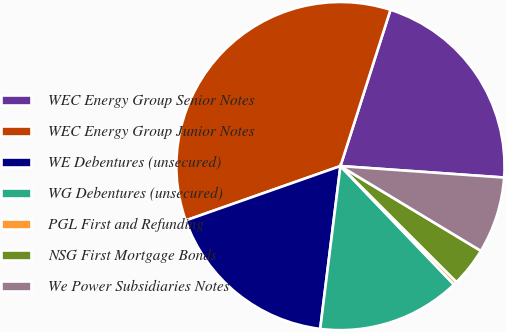Convert chart. <chart><loc_0><loc_0><loc_500><loc_500><pie_chart><fcel>WEC Energy Group Senior Notes<fcel>WEC Energy Group Junior Notes<fcel>WE Debentures (unsecured)<fcel>WG Debentures (unsecured)<fcel>PGL First and Refunding<fcel>NSG First Mortgage Bonds<fcel>We Power Subsidiaries Notes<nl><fcel>21.18%<fcel>35.31%<fcel>17.65%<fcel>14.12%<fcel>0.35%<fcel>3.85%<fcel>7.53%<nl></chart> 